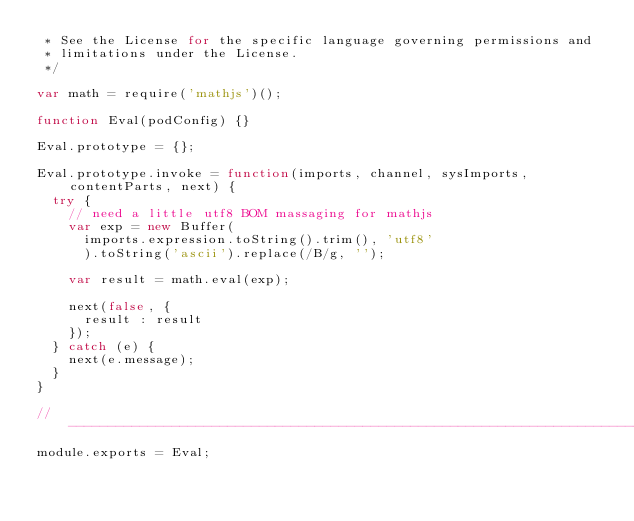Convert code to text. <code><loc_0><loc_0><loc_500><loc_500><_JavaScript_> * See the License for the specific language governing permissions and
 * limitations under the License.
 */

var math = require('mathjs')();

function Eval(podConfig) {}

Eval.prototype = {};

Eval.prototype.invoke = function(imports, channel, sysImports, contentParts, next) {
  try {
    // need a little utf8 BOM massaging for mathjs
    var exp = new Buffer(
      imports.expression.toString().trim(), 'utf8'
      ).toString('ascii').replace(/B/g, '');

    var result = math.eval(exp);

    next(false, {
      result : result
    });
  } catch (e) {
    next(e.message);
  }
}

// -----------------------------------------------------------------------------
module.exports = Eval;
</code> 